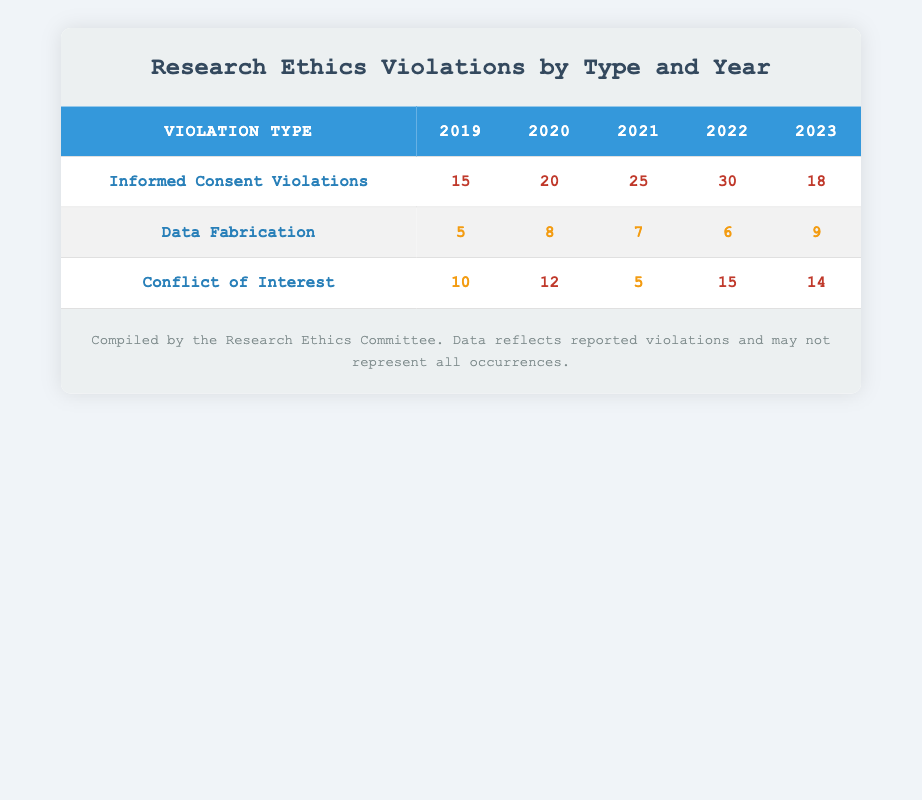What were the reported instances of Informed Consent Violations in 2021? Referring to the table, the count for Informed Consent Violations in 2021 is noted as 25.
Answer: 25 What is the total number of Conflict of Interest violations reported from 2019 to 2023? By adding the counts for Conflict of Interest violations across the years: 10 (2019) + 12 (2020) + 5 (2021) + 15 (2022) + 14 (2023) = 56.
Answer: 56 Was there an increase in Data Fabrication violations from 2020 to 2021? Looking at the counts, in 2020 there were 8 Data Fabrication violations, and in 2021 there were 7. Since 7 is less than 8, this indicates a decrease.
Answer: No What is the average number of Informed Consent Violations over the years 2020 to 2023? The counts from 2020 to 2023 are: 20 (2020), 25 (2021), 30 (2022), and 18 (2023). The total is 20 + 25 + 30 + 18 = 93, and dividing by the 4 years gives an average of 93/4 = 23.25.
Answer: 23.25 Which year had the highest number of Data Fabrication violations? Comparing the counts for Data Fabrication across the years: 5 (2019), 8 (2020), 7 (2021), 6 (2022), and 9 (2023), 2023 has the highest at 9.
Answer: 2023 Did the number of Informed Consent Violations exceed 30 in any year? Checking the counts for Informed Consent Violations: 15 (2019), 20 (2020), 25 (2021), 30 (2022), and 18 (2023). Only 2022 reached exactly 30, none exceeded it.
Answer: No What was the difference in the number of Conflict of Interest violations from 2019 to 2022? The counts are 10 (2019) and 15 (2022). The difference is 15 - 10 = 5, indicating an increase from 2019 to 2022.
Answer: 5 What percentage of reported violations in 2022 were related to Conflict of Interest? In 2022, there were a total of 30 (Informed Consent) + 6 (Data Fabrication) + 15 (Conflict of Interest) = 51 total violations. The count for Conflict of Interest is 15. The percentage is (15/51) * 100 = 29.41%.
Answer: 29.41% Was the total number of violations in 2020 greater than those in 2021? The total violations in 2020 are 20 (Informed Consent) + 8 (Data Fabrication) + 12 (Conflict of Interest) = 40. In 2021, the total is 25 + 7 + 5 = 37. Since 40 is greater than 37, the answer is yes.
Answer: Yes 